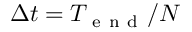Convert formula to latex. <formula><loc_0><loc_0><loc_500><loc_500>\Delta t = T _ { e n d } / N</formula> 